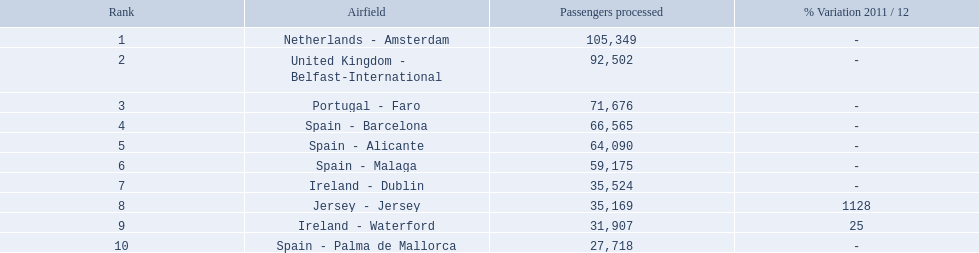What are all of the routes out of the london southend airport? Netherlands - Amsterdam, United Kingdom - Belfast-International, Portugal - Faro, Spain - Barcelona, Spain - Alicante, Spain - Malaga, Ireland - Dublin, Jersey - Jersey, Ireland - Waterford, Spain - Palma de Mallorca. I'm looking to parse the entire table for insights. Could you assist me with that? {'header': ['Rank', 'Airfield', 'Passengers processed', '% Variation 2011 / 12'], 'rows': [['1', 'Netherlands - Amsterdam', '105,349', '-'], ['2', 'United Kingdom - Belfast-International', '92,502', '-'], ['3', 'Portugal - Faro', '71,676', '-'], ['4', 'Spain - Barcelona', '66,565', '-'], ['5', 'Spain - Alicante', '64,090', '-'], ['6', 'Spain - Malaga', '59,175', '-'], ['7', 'Ireland - Dublin', '35,524', '-'], ['8', 'Jersey - Jersey', '35,169', '1128'], ['9', 'Ireland - Waterford', '31,907', '25'], ['10', 'Spain - Palma de Mallorca', '27,718', '-']]} How many passengers have traveled to each destination? 105,349, 92,502, 71,676, 66,565, 64,090, 59,175, 35,524, 35,169, 31,907, 27,718. And which destination has been the most popular to passengers? Netherlands - Amsterdam. 